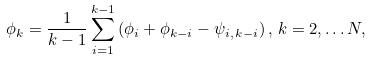<formula> <loc_0><loc_0><loc_500><loc_500>\phi _ { k } = \frac { 1 } { k - 1 } \sum _ { i = 1 } ^ { k - 1 } \, ( \phi _ { i } + \phi _ { k - i } - \psi _ { i , \, k - i } ) \, , \, k = 2 , \dots N ,</formula> 